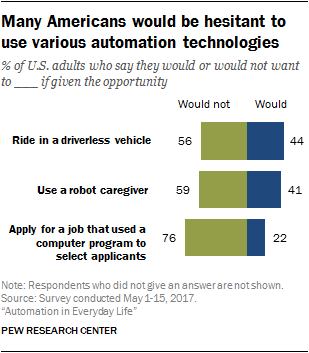Outline some significant characteristics in this image. According to the survey results, when asked about the highest distribution between a ride in a driverless vehicle and use a robot caregiver, the respondents answered 59%. The highest value of the green bar is 76. 